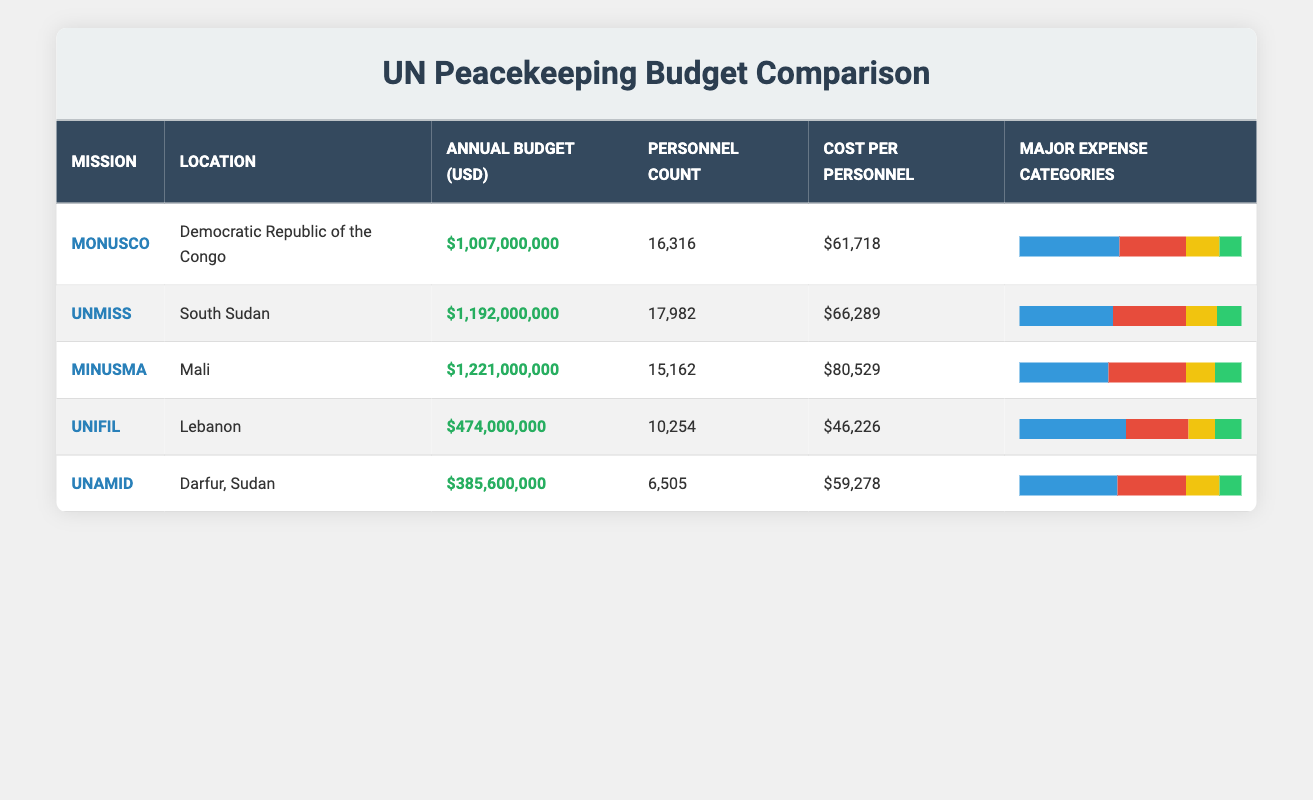What is the annual budget of UNMISS? The table indicates that the annual budget of UNMISS is listed directly in the corresponding row under Annual Budget (USD). The specific value is $1,192,000,000.
Answer: $1,192,000,000 Which mission has the highest cost per personnel? By comparing the Cost Per Personnel column for each mission, MINUSMA has the highest cost per personnel at $80,529.
Answer: $80,529 What percentage of the total budget does troop costs account for in MONUSCO? The Major Expense Categories for MONUSCO indicate that troop costs account for 45% of its budget. This is found in the relevant section of the table.
Answer: 45% Is the total annual budget of MONUSCO greater than the combined budgets of UNIFIL and UNAMID? The annual budgets are $1,007,000,000 for MONUSCO, $474,000,000 for UNIFIL, and $385,600,000 for UNAMID. First, calculate the combined budgets of UNIFIL and UNAMID: $474,000,000 + $385,600,000 = $859,600,000. Since $1,007,000,000 is greater than $859,600,000, the answer is yes.
Answer: Yes Which mission has the lowest personnel count and what is it? The personnel counts for each mission list UNAMID with the lowest count at 6,505. This can be found by comparing the Personnel Count column across all missions.
Answer: 6,505 What is the average budget of all listed missions? First, sum all the annual budgets: $1,007,000,000 (MONUSCO) + $1,192,000,000 (UNMISS) + $1,221,000,000 (MINUSMA) + $474,000,000 (UNIFIL) + $385,600,000 (UNAMID) = $4,280,600,000. Then, divide by the number of missions (5): $4,280,600,000 / 5 = $856,120,000.
Answer: $856,120,000 Are the operational costs for UNIFIL more than 30% of its budget? From the Major Expense Categories for UNIFIL, operational costs are stated as 28%. Since 28% is less than 30%, the answer is no.
Answer: No How does the cost per personnel of MINUSMA compare to that of UNMISS? MINUSMA has a cost per personnel of $80,529 while UNMISS has $66,289. Comparing the two values, $80,529 is greater than $66,289, meaning MINUSMA has a higher cost per personnel.
Answer: Higher What is the total personnel count across all missions? To find the total personnel count, sum the counts for all missions: 16,316 (MONUSCO) + 17,982 (UNMISS) + 15,162 (MINUSMA) + 10,254 (UNIFIL) + 6,505 (UNAMID) = 66,219.
Answer: 66,219 